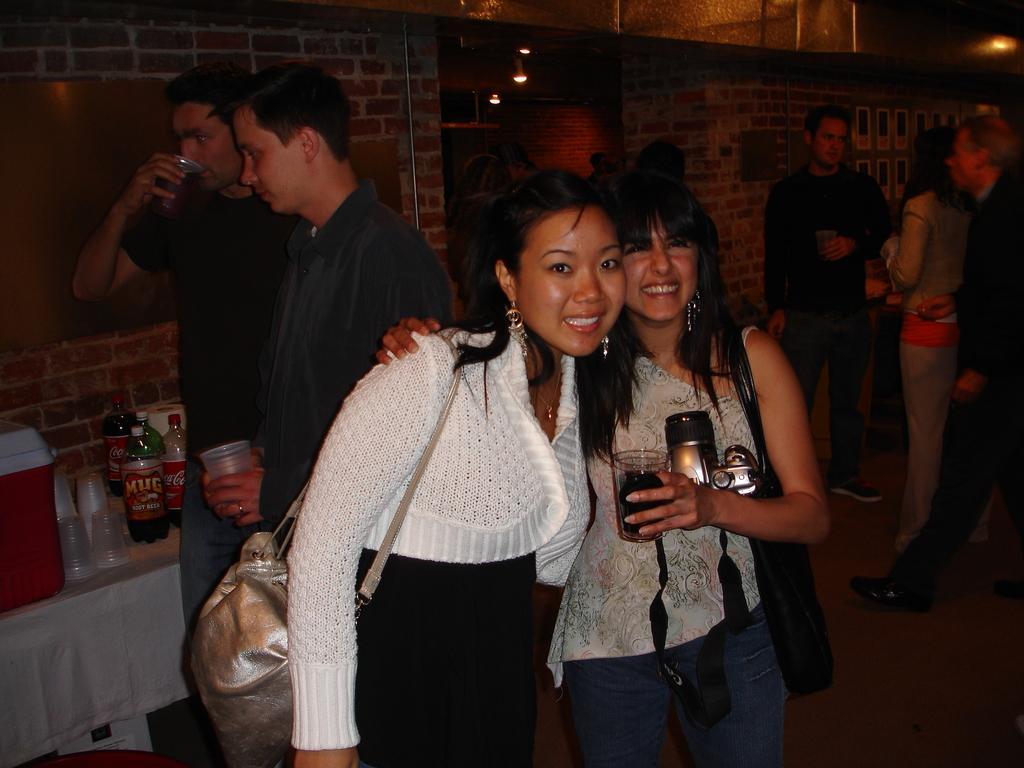Describe this image in one or two sentences. In this image there are two persons standing and smiling, a person holding a glass, and in the background there are group of people standing , bottles , glasses, ice cooler cube on the table, frames attached to the wall, lights. 